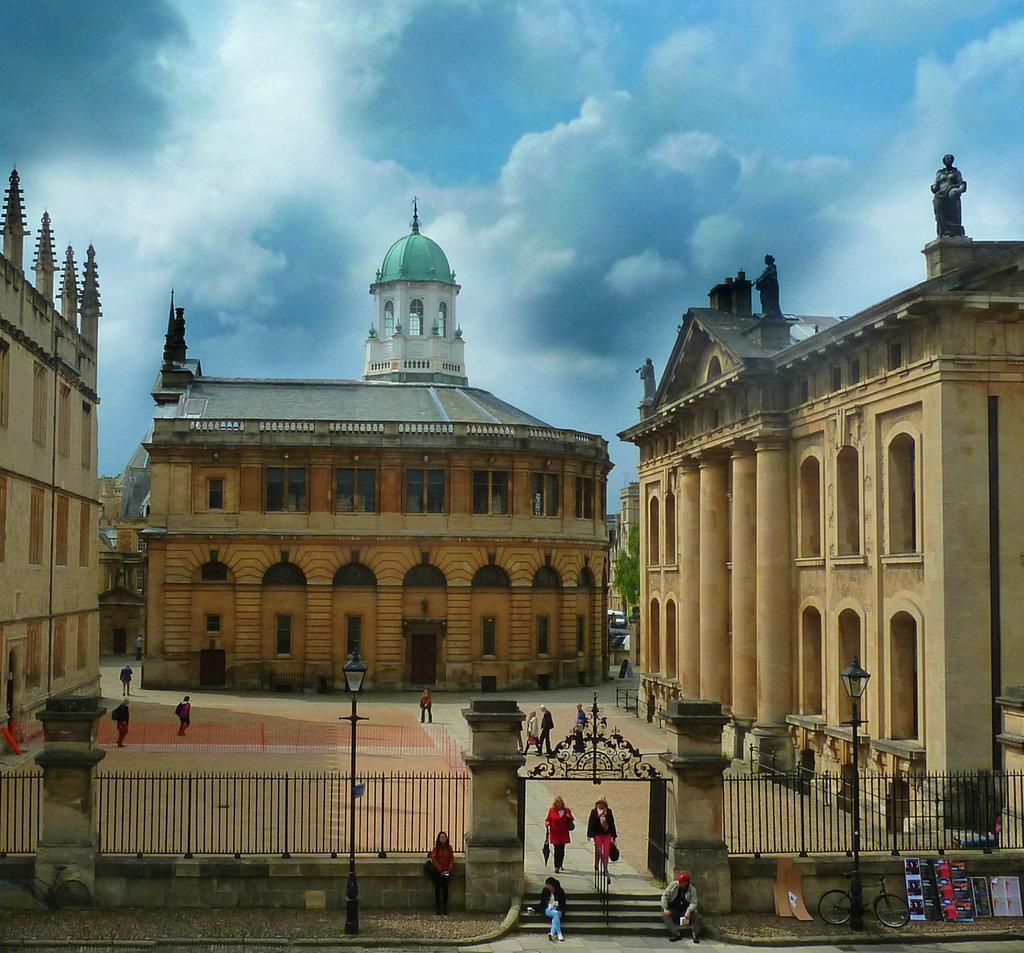How would you summarize this image in a sentence or two? The picture is taken outside a city. In the center of the picture there are buildings. In the foreground of the picture there are street lights, railing and people. At the bottom there is road and pavement. Sky is cloudy. 